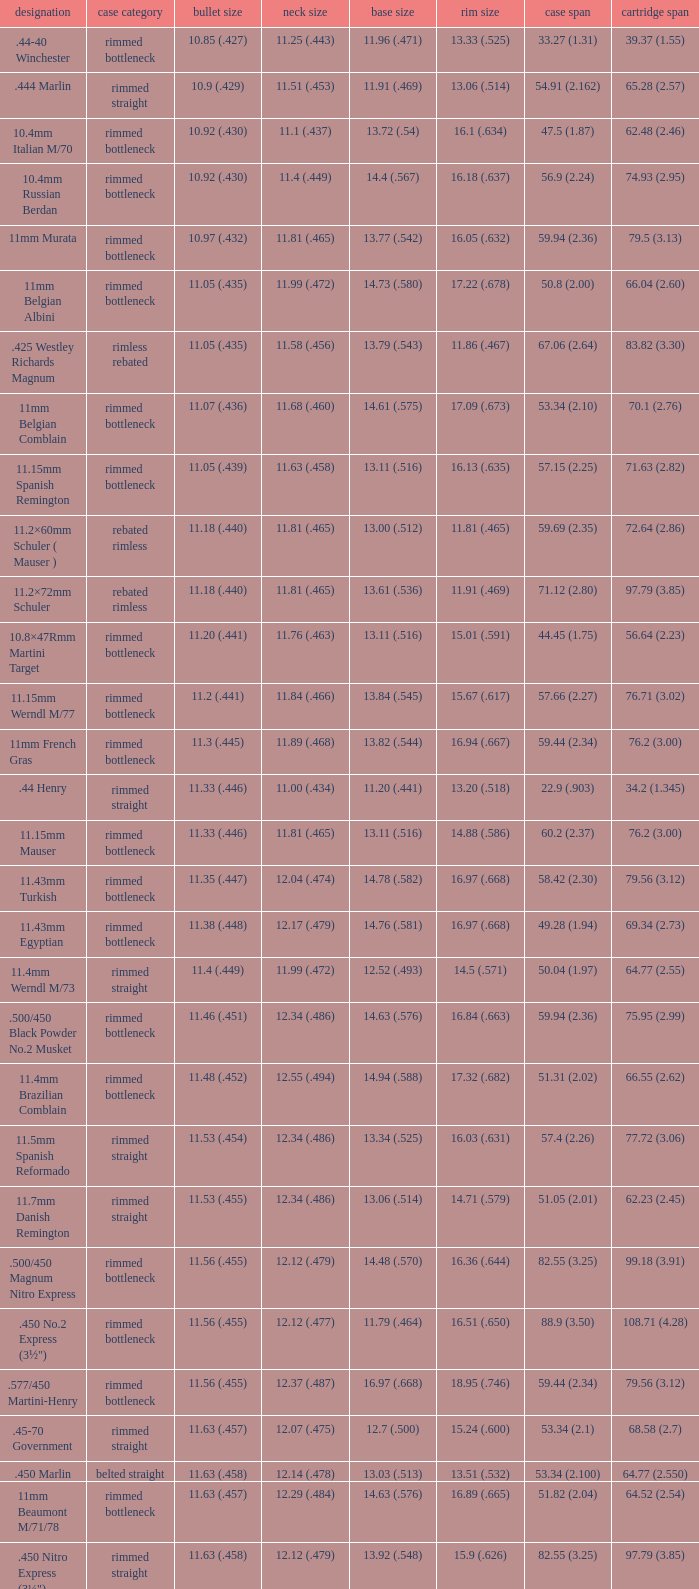Which Bullet diameter has a Neck diameter of 12.17 (.479)? 11.38 (.448). 